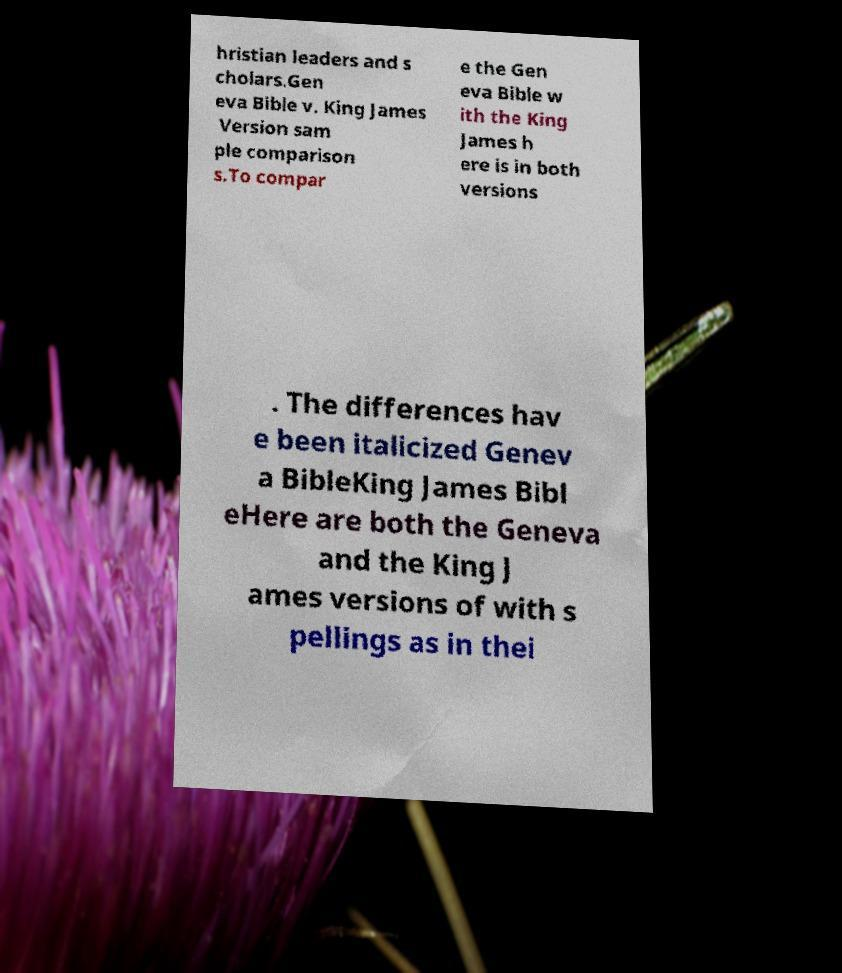Please identify and transcribe the text found in this image. hristian leaders and s cholars.Gen eva Bible v. King James Version sam ple comparison s.To compar e the Gen eva Bible w ith the King James h ere is in both versions . The differences hav e been italicized Genev a BibleKing James Bibl eHere are both the Geneva and the King J ames versions of with s pellings as in thei 